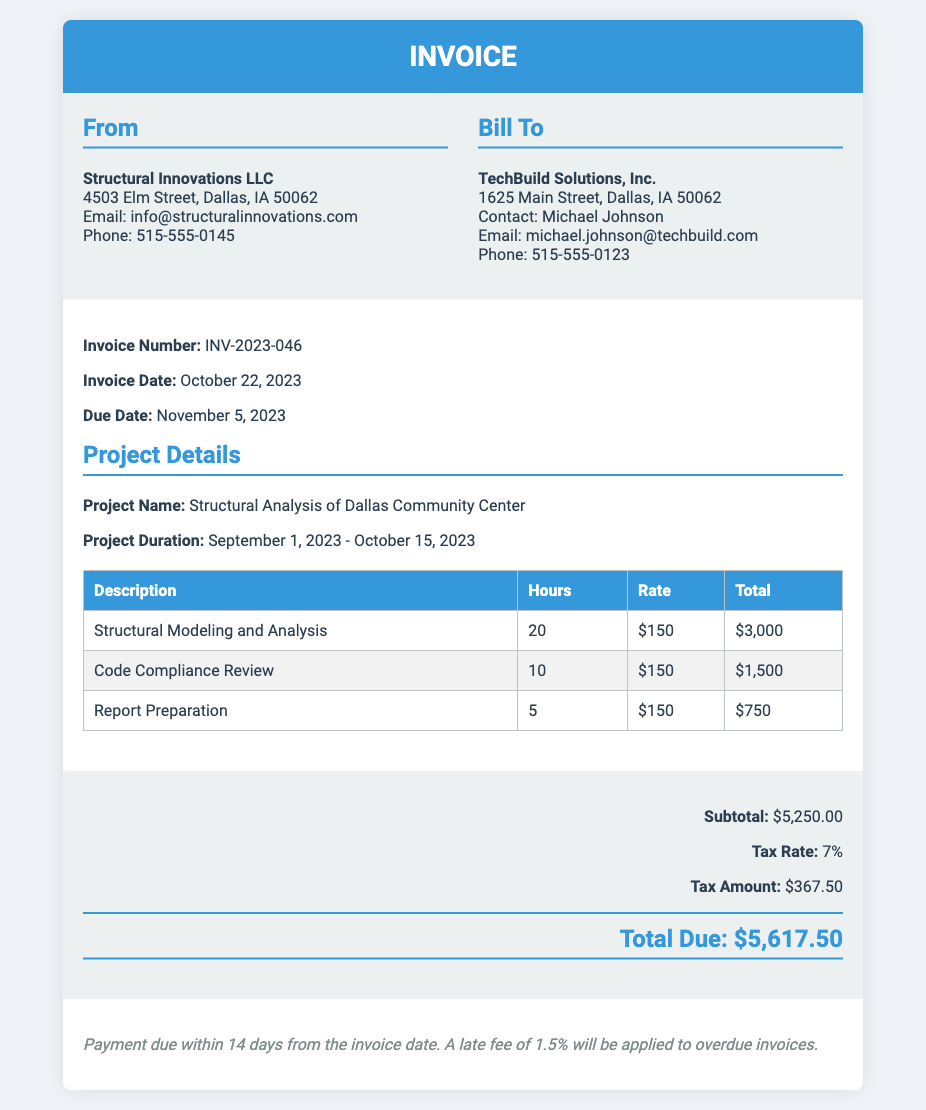What is the invoice number? The invoice number is listed at the top of the document, which is INV-2023-046.
Answer: INV-2023-046 Who is the client? The client is identified in the "Bill To" section of the document as TechBuild Solutions, Inc.
Answer: TechBuild Solutions, Inc What is the total due amount? The total due amount is highlighted at the bottom of the document, which is $5,617.50.
Answer: $5,617.50 What is the tax amount? The tax amount is specified in the summary section, which totals $367.50.
Answer: $367.50 How many hours were spent on Structural Modeling and Analysis? The hours for Structural Modeling and Analysis are detailed in the services table, indicating 20 hours.
Answer: 20 What is the hourly rate for the services? The hourly rate for the services is consistently stated as $150 across all tasks in the document.
Answer: $150 What is the due date for the invoice? The due date is listed under the invoice date section as November 5, 2023.
Answer: November 5, 2023 When did the project duration start? The project duration start date is specified as September 1, 2023, in the document.
Answer: September 1, 2023 How long is the payment term? The payment term is mentioned as due within 14 days from the invoice date.
Answer: 14 days 